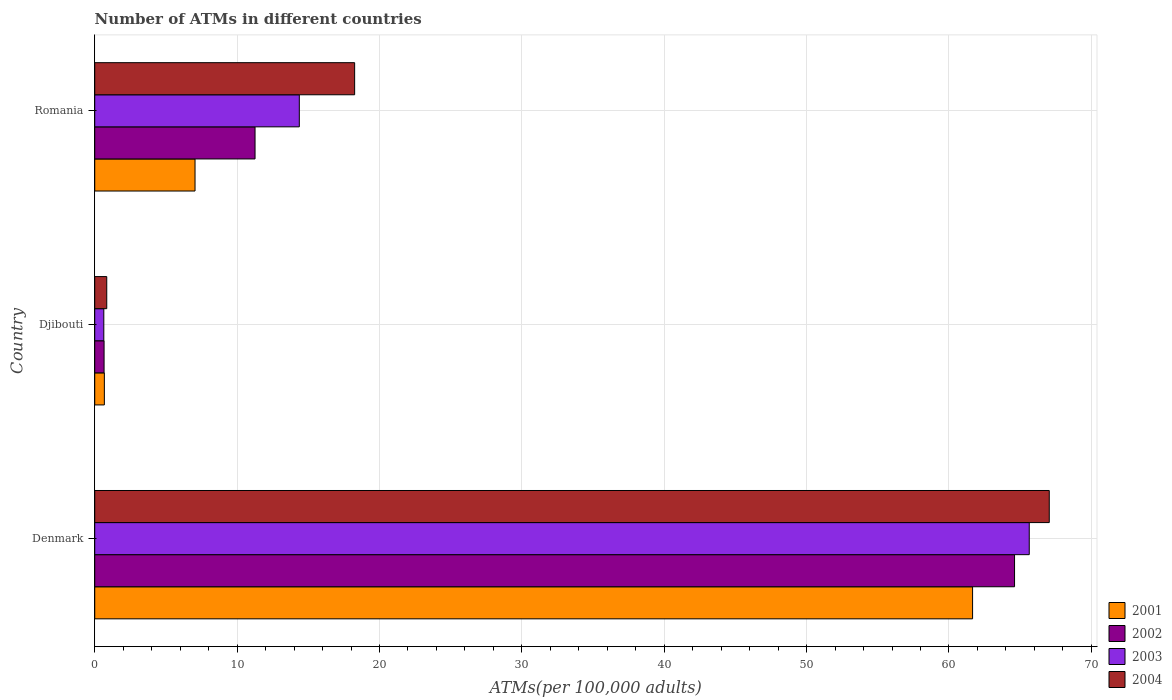How many groups of bars are there?
Provide a succinct answer. 3. Are the number of bars per tick equal to the number of legend labels?
Provide a succinct answer. Yes. Are the number of bars on each tick of the Y-axis equal?
Give a very brief answer. Yes. How many bars are there on the 1st tick from the bottom?
Provide a short and direct response. 4. What is the label of the 1st group of bars from the top?
Provide a succinct answer. Romania. What is the number of ATMs in 2004 in Denmark?
Keep it short and to the point. 67.04. Across all countries, what is the maximum number of ATMs in 2004?
Provide a short and direct response. 67.04. Across all countries, what is the minimum number of ATMs in 2003?
Provide a succinct answer. 0.64. In which country was the number of ATMs in 2001 minimum?
Your answer should be very brief. Djibouti. What is the total number of ATMs in 2003 in the graph?
Your answer should be compact. 80.65. What is the difference between the number of ATMs in 2003 in Djibouti and that in Romania?
Give a very brief answer. -13.73. What is the difference between the number of ATMs in 2003 in Denmark and the number of ATMs in 2002 in Djibouti?
Give a very brief answer. 64.98. What is the average number of ATMs in 2003 per country?
Your answer should be very brief. 26.88. What is the difference between the number of ATMs in 2003 and number of ATMs in 2004 in Djibouti?
Ensure brevity in your answer.  -0.21. In how many countries, is the number of ATMs in 2001 greater than 12 ?
Keep it short and to the point. 1. What is the ratio of the number of ATMs in 2002 in Denmark to that in Djibouti?
Your response must be concise. 98.45. Is the difference between the number of ATMs in 2003 in Djibouti and Romania greater than the difference between the number of ATMs in 2004 in Djibouti and Romania?
Offer a very short reply. Yes. What is the difference between the highest and the second highest number of ATMs in 2002?
Your answer should be compact. 53.35. What is the difference between the highest and the lowest number of ATMs in 2001?
Offer a terse response. 60.98. Is it the case that in every country, the sum of the number of ATMs in 2001 and number of ATMs in 2002 is greater than the sum of number of ATMs in 2004 and number of ATMs in 2003?
Keep it short and to the point. No. What does the 3rd bar from the top in Denmark represents?
Keep it short and to the point. 2002. Are all the bars in the graph horizontal?
Provide a short and direct response. Yes. What is the difference between two consecutive major ticks on the X-axis?
Make the answer very short. 10. Where does the legend appear in the graph?
Provide a short and direct response. Bottom right. How many legend labels are there?
Your answer should be very brief. 4. How are the legend labels stacked?
Your answer should be compact. Vertical. What is the title of the graph?
Your answer should be compact. Number of ATMs in different countries. Does "1978" appear as one of the legend labels in the graph?
Provide a short and direct response. No. What is the label or title of the X-axis?
Your response must be concise. ATMs(per 100,0 adults). What is the ATMs(per 100,000 adults) of 2001 in Denmark?
Offer a terse response. 61.66. What is the ATMs(per 100,000 adults) in 2002 in Denmark?
Make the answer very short. 64.61. What is the ATMs(per 100,000 adults) of 2003 in Denmark?
Offer a terse response. 65.64. What is the ATMs(per 100,000 adults) in 2004 in Denmark?
Keep it short and to the point. 67.04. What is the ATMs(per 100,000 adults) in 2001 in Djibouti?
Ensure brevity in your answer.  0.68. What is the ATMs(per 100,000 adults) in 2002 in Djibouti?
Your answer should be very brief. 0.66. What is the ATMs(per 100,000 adults) in 2003 in Djibouti?
Provide a succinct answer. 0.64. What is the ATMs(per 100,000 adults) in 2004 in Djibouti?
Offer a terse response. 0.84. What is the ATMs(per 100,000 adults) in 2001 in Romania?
Provide a short and direct response. 7.04. What is the ATMs(per 100,000 adults) in 2002 in Romania?
Keep it short and to the point. 11.26. What is the ATMs(per 100,000 adults) of 2003 in Romania?
Make the answer very short. 14.37. What is the ATMs(per 100,000 adults) of 2004 in Romania?
Your answer should be very brief. 18.26. Across all countries, what is the maximum ATMs(per 100,000 adults) in 2001?
Offer a terse response. 61.66. Across all countries, what is the maximum ATMs(per 100,000 adults) of 2002?
Your answer should be compact. 64.61. Across all countries, what is the maximum ATMs(per 100,000 adults) in 2003?
Offer a terse response. 65.64. Across all countries, what is the maximum ATMs(per 100,000 adults) of 2004?
Give a very brief answer. 67.04. Across all countries, what is the minimum ATMs(per 100,000 adults) in 2001?
Keep it short and to the point. 0.68. Across all countries, what is the minimum ATMs(per 100,000 adults) in 2002?
Offer a terse response. 0.66. Across all countries, what is the minimum ATMs(per 100,000 adults) in 2003?
Offer a very short reply. 0.64. Across all countries, what is the minimum ATMs(per 100,000 adults) in 2004?
Provide a succinct answer. 0.84. What is the total ATMs(per 100,000 adults) in 2001 in the graph?
Ensure brevity in your answer.  69.38. What is the total ATMs(per 100,000 adults) in 2002 in the graph?
Offer a terse response. 76.52. What is the total ATMs(per 100,000 adults) of 2003 in the graph?
Provide a succinct answer. 80.65. What is the total ATMs(per 100,000 adults) in 2004 in the graph?
Provide a succinct answer. 86.14. What is the difference between the ATMs(per 100,000 adults) in 2001 in Denmark and that in Djibouti?
Make the answer very short. 60.98. What is the difference between the ATMs(per 100,000 adults) of 2002 in Denmark and that in Djibouti?
Provide a succinct answer. 63.95. What is the difference between the ATMs(per 100,000 adults) in 2003 in Denmark and that in Djibouti?
Offer a terse response. 65. What is the difference between the ATMs(per 100,000 adults) of 2004 in Denmark and that in Djibouti?
Offer a terse response. 66.2. What is the difference between the ATMs(per 100,000 adults) in 2001 in Denmark and that in Romania?
Make the answer very short. 54.61. What is the difference between the ATMs(per 100,000 adults) in 2002 in Denmark and that in Romania?
Your answer should be compact. 53.35. What is the difference between the ATMs(per 100,000 adults) in 2003 in Denmark and that in Romania?
Offer a very short reply. 51.27. What is the difference between the ATMs(per 100,000 adults) of 2004 in Denmark and that in Romania?
Make the answer very short. 48.79. What is the difference between the ATMs(per 100,000 adults) of 2001 in Djibouti and that in Romania?
Give a very brief answer. -6.37. What is the difference between the ATMs(per 100,000 adults) in 2002 in Djibouti and that in Romania?
Your response must be concise. -10.6. What is the difference between the ATMs(per 100,000 adults) of 2003 in Djibouti and that in Romania?
Provide a short and direct response. -13.73. What is the difference between the ATMs(per 100,000 adults) of 2004 in Djibouti and that in Romania?
Provide a short and direct response. -17.41. What is the difference between the ATMs(per 100,000 adults) of 2001 in Denmark and the ATMs(per 100,000 adults) of 2002 in Djibouti?
Give a very brief answer. 61. What is the difference between the ATMs(per 100,000 adults) of 2001 in Denmark and the ATMs(per 100,000 adults) of 2003 in Djibouti?
Provide a short and direct response. 61.02. What is the difference between the ATMs(per 100,000 adults) in 2001 in Denmark and the ATMs(per 100,000 adults) in 2004 in Djibouti?
Your response must be concise. 60.81. What is the difference between the ATMs(per 100,000 adults) in 2002 in Denmark and the ATMs(per 100,000 adults) in 2003 in Djibouti?
Ensure brevity in your answer.  63.97. What is the difference between the ATMs(per 100,000 adults) in 2002 in Denmark and the ATMs(per 100,000 adults) in 2004 in Djibouti?
Provide a succinct answer. 63.76. What is the difference between the ATMs(per 100,000 adults) in 2003 in Denmark and the ATMs(per 100,000 adults) in 2004 in Djibouti?
Give a very brief answer. 64.79. What is the difference between the ATMs(per 100,000 adults) of 2001 in Denmark and the ATMs(per 100,000 adults) of 2002 in Romania?
Your answer should be compact. 50.4. What is the difference between the ATMs(per 100,000 adults) of 2001 in Denmark and the ATMs(per 100,000 adults) of 2003 in Romania?
Make the answer very short. 47.29. What is the difference between the ATMs(per 100,000 adults) of 2001 in Denmark and the ATMs(per 100,000 adults) of 2004 in Romania?
Keep it short and to the point. 43.4. What is the difference between the ATMs(per 100,000 adults) of 2002 in Denmark and the ATMs(per 100,000 adults) of 2003 in Romania?
Your answer should be compact. 50.24. What is the difference between the ATMs(per 100,000 adults) in 2002 in Denmark and the ATMs(per 100,000 adults) in 2004 in Romania?
Keep it short and to the point. 46.35. What is the difference between the ATMs(per 100,000 adults) in 2003 in Denmark and the ATMs(per 100,000 adults) in 2004 in Romania?
Your response must be concise. 47.38. What is the difference between the ATMs(per 100,000 adults) of 2001 in Djibouti and the ATMs(per 100,000 adults) of 2002 in Romania?
Your response must be concise. -10.58. What is the difference between the ATMs(per 100,000 adults) in 2001 in Djibouti and the ATMs(per 100,000 adults) in 2003 in Romania?
Your response must be concise. -13.69. What is the difference between the ATMs(per 100,000 adults) of 2001 in Djibouti and the ATMs(per 100,000 adults) of 2004 in Romania?
Your answer should be very brief. -17.58. What is the difference between the ATMs(per 100,000 adults) of 2002 in Djibouti and the ATMs(per 100,000 adults) of 2003 in Romania?
Offer a terse response. -13.71. What is the difference between the ATMs(per 100,000 adults) of 2002 in Djibouti and the ATMs(per 100,000 adults) of 2004 in Romania?
Ensure brevity in your answer.  -17.6. What is the difference between the ATMs(per 100,000 adults) in 2003 in Djibouti and the ATMs(per 100,000 adults) in 2004 in Romania?
Make the answer very short. -17.62. What is the average ATMs(per 100,000 adults) in 2001 per country?
Provide a succinct answer. 23.13. What is the average ATMs(per 100,000 adults) in 2002 per country?
Offer a very short reply. 25.51. What is the average ATMs(per 100,000 adults) in 2003 per country?
Make the answer very short. 26.88. What is the average ATMs(per 100,000 adults) in 2004 per country?
Keep it short and to the point. 28.71. What is the difference between the ATMs(per 100,000 adults) of 2001 and ATMs(per 100,000 adults) of 2002 in Denmark?
Your answer should be very brief. -2.95. What is the difference between the ATMs(per 100,000 adults) of 2001 and ATMs(per 100,000 adults) of 2003 in Denmark?
Keep it short and to the point. -3.98. What is the difference between the ATMs(per 100,000 adults) of 2001 and ATMs(per 100,000 adults) of 2004 in Denmark?
Keep it short and to the point. -5.39. What is the difference between the ATMs(per 100,000 adults) of 2002 and ATMs(per 100,000 adults) of 2003 in Denmark?
Offer a terse response. -1.03. What is the difference between the ATMs(per 100,000 adults) in 2002 and ATMs(per 100,000 adults) in 2004 in Denmark?
Offer a very short reply. -2.44. What is the difference between the ATMs(per 100,000 adults) of 2003 and ATMs(per 100,000 adults) of 2004 in Denmark?
Keep it short and to the point. -1.41. What is the difference between the ATMs(per 100,000 adults) of 2001 and ATMs(per 100,000 adults) of 2002 in Djibouti?
Your answer should be very brief. 0.02. What is the difference between the ATMs(per 100,000 adults) of 2001 and ATMs(per 100,000 adults) of 2003 in Djibouti?
Your answer should be very brief. 0.04. What is the difference between the ATMs(per 100,000 adults) in 2001 and ATMs(per 100,000 adults) in 2004 in Djibouti?
Ensure brevity in your answer.  -0.17. What is the difference between the ATMs(per 100,000 adults) of 2002 and ATMs(per 100,000 adults) of 2003 in Djibouti?
Keep it short and to the point. 0.02. What is the difference between the ATMs(per 100,000 adults) of 2002 and ATMs(per 100,000 adults) of 2004 in Djibouti?
Offer a very short reply. -0.19. What is the difference between the ATMs(per 100,000 adults) of 2003 and ATMs(per 100,000 adults) of 2004 in Djibouti?
Ensure brevity in your answer.  -0.21. What is the difference between the ATMs(per 100,000 adults) of 2001 and ATMs(per 100,000 adults) of 2002 in Romania?
Give a very brief answer. -4.21. What is the difference between the ATMs(per 100,000 adults) in 2001 and ATMs(per 100,000 adults) in 2003 in Romania?
Your answer should be very brief. -7.32. What is the difference between the ATMs(per 100,000 adults) of 2001 and ATMs(per 100,000 adults) of 2004 in Romania?
Ensure brevity in your answer.  -11.21. What is the difference between the ATMs(per 100,000 adults) of 2002 and ATMs(per 100,000 adults) of 2003 in Romania?
Give a very brief answer. -3.11. What is the difference between the ATMs(per 100,000 adults) of 2002 and ATMs(per 100,000 adults) of 2004 in Romania?
Offer a very short reply. -7. What is the difference between the ATMs(per 100,000 adults) in 2003 and ATMs(per 100,000 adults) in 2004 in Romania?
Your answer should be compact. -3.89. What is the ratio of the ATMs(per 100,000 adults) in 2001 in Denmark to that in Djibouti?
Provide a succinct answer. 91.18. What is the ratio of the ATMs(per 100,000 adults) in 2002 in Denmark to that in Djibouti?
Offer a terse response. 98.45. What is the ratio of the ATMs(per 100,000 adults) in 2003 in Denmark to that in Djibouti?
Ensure brevity in your answer.  102.88. What is the ratio of the ATMs(per 100,000 adults) in 2004 in Denmark to that in Djibouti?
Provide a short and direct response. 79.46. What is the ratio of the ATMs(per 100,000 adults) of 2001 in Denmark to that in Romania?
Your answer should be very brief. 8.75. What is the ratio of the ATMs(per 100,000 adults) of 2002 in Denmark to that in Romania?
Keep it short and to the point. 5.74. What is the ratio of the ATMs(per 100,000 adults) of 2003 in Denmark to that in Romania?
Give a very brief answer. 4.57. What is the ratio of the ATMs(per 100,000 adults) of 2004 in Denmark to that in Romania?
Keep it short and to the point. 3.67. What is the ratio of the ATMs(per 100,000 adults) in 2001 in Djibouti to that in Romania?
Give a very brief answer. 0.1. What is the ratio of the ATMs(per 100,000 adults) of 2002 in Djibouti to that in Romania?
Give a very brief answer. 0.06. What is the ratio of the ATMs(per 100,000 adults) of 2003 in Djibouti to that in Romania?
Your answer should be compact. 0.04. What is the ratio of the ATMs(per 100,000 adults) in 2004 in Djibouti to that in Romania?
Your answer should be very brief. 0.05. What is the difference between the highest and the second highest ATMs(per 100,000 adults) of 2001?
Offer a terse response. 54.61. What is the difference between the highest and the second highest ATMs(per 100,000 adults) in 2002?
Give a very brief answer. 53.35. What is the difference between the highest and the second highest ATMs(per 100,000 adults) in 2003?
Give a very brief answer. 51.27. What is the difference between the highest and the second highest ATMs(per 100,000 adults) of 2004?
Keep it short and to the point. 48.79. What is the difference between the highest and the lowest ATMs(per 100,000 adults) of 2001?
Provide a succinct answer. 60.98. What is the difference between the highest and the lowest ATMs(per 100,000 adults) in 2002?
Keep it short and to the point. 63.95. What is the difference between the highest and the lowest ATMs(per 100,000 adults) in 2003?
Your answer should be compact. 65. What is the difference between the highest and the lowest ATMs(per 100,000 adults) in 2004?
Keep it short and to the point. 66.2. 